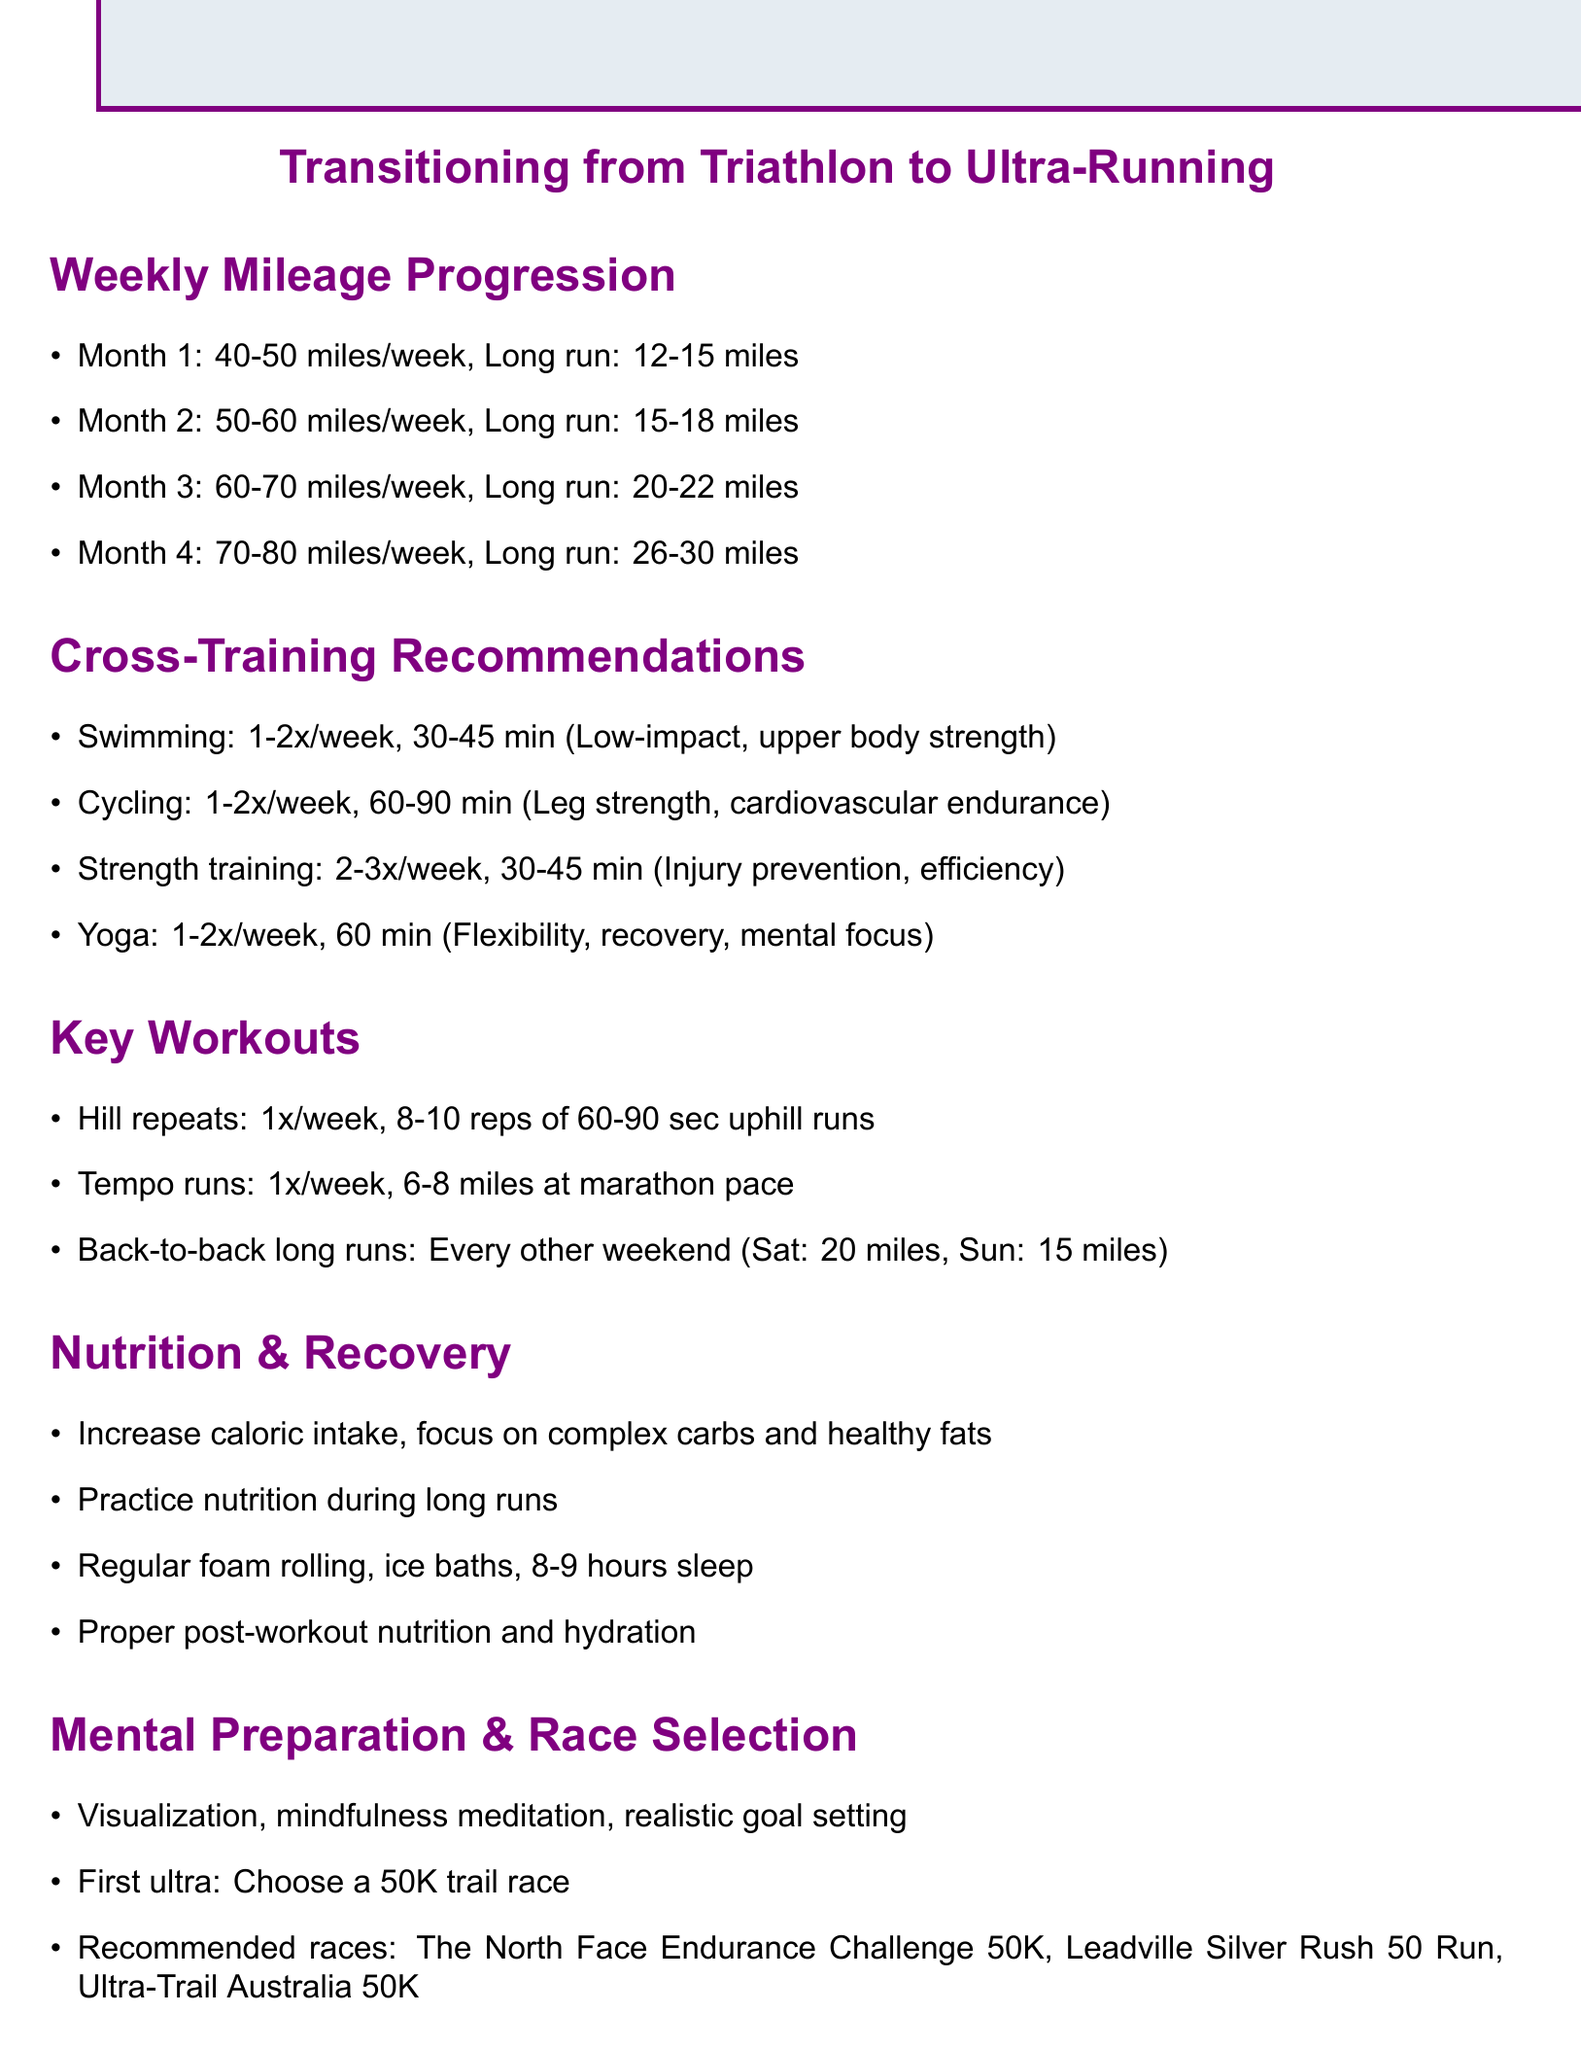What is the weekly mileage for month 3? The document specifies that the weekly mileage for month 3 is between 60-70 miles.
Answer: 60-70 miles How many times per week is swimming recommended? According to the cross-training recommendations, swimming should be done 1-2 times per week.
Answer: 1-2 times What is the duration for strength training? The document states that strength training should last for 30-45 minutes each session.
Answer: 30-45 minutes What is one key workout suggested for improving endurance? The document mentions hill repeats as a key workout for endurance training.
Answer: Hill repeats How many calories should an ultra-runner increase intake to support higher mileage? The document advises increasing caloric intake, but does not specify a number.
Answer: Increase caloric intake What is the suggested long run distance for month 4? For month 4, the suggested long run distance is between 26-30 miles.
Answer: 26-30 miles Which race is recommended for a first ultra-marathon? The document recommends choosing a 50K trail race for the first ultra-marathon.
Answer: 50K trail race How often should yoga be practiced according to the recommendations? The document suggests practicing yoga 1-2 times per week.
Answer: 1-2 times 